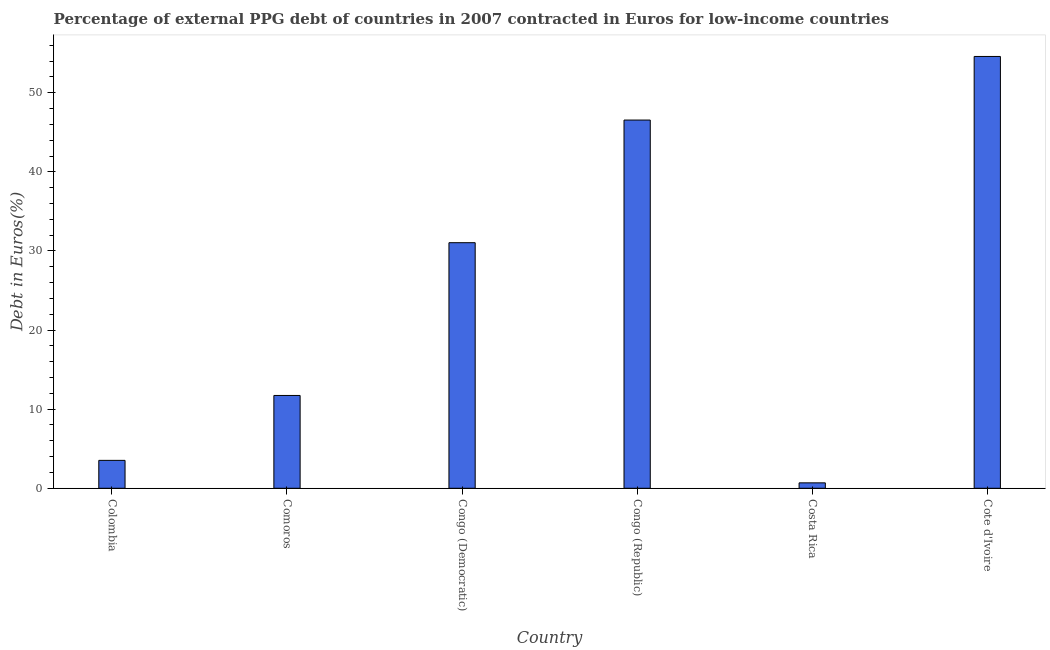Does the graph contain any zero values?
Ensure brevity in your answer.  No. What is the title of the graph?
Your response must be concise. Percentage of external PPG debt of countries in 2007 contracted in Euros for low-income countries. What is the label or title of the Y-axis?
Offer a very short reply. Debt in Euros(%). What is the currency composition of ppg debt in Costa Rica?
Provide a short and direct response. 0.69. Across all countries, what is the maximum currency composition of ppg debt?
Your answer should be compact. 54.59. Across all countries, what is the minimum currency composition of ppg debt?
Offer a very short reply. 0.69. In which country was the currency composition of ppg debt maximum?
Offer a terse response. Cote d'Ivoire. In which country was the currency composition of ppg debt minimum?
Provide a succinct answer. Costa Rica. What is the sum of the currency composition of ppg debt?
Your response must be concise. 148.14. What is the difference between the currency composition of ppg debt in Colombia and Comoros?
Ensure brevity in your answer.  -8.2. What is the average currency composition of ppg debt per country?
Offer a terse response. 24.69. What is the median currency composition of ppg debt?
Keep it short and to the point. 21.39. What is the ratio of the currency composition of ppg debt in Congo (Republic) to that in Cote d'Ivoire?
Your answer should be compact. 0.85. What is the difference between the highest and the second highest currency composition of ppg debt?
Provide a short and direct response. 8.04. Is the sum of the currency composition of ppg debt in Congo (Democratic) and Cote d'Ivoire greater than the maximum currency composition of ppg debt across all countries?
Keep it short and to the point. Yes. What is the difference between the highest and the lowest currency composition of ppg debt?
Offer a very short reply. 53.9. In how many countries, is the currency composition of ppg debt greater than the average currency composition of ppg debt taken over all countries?
Your answer should be very brief. 3. Are all the bars in the graph horizontal?
Your answer should be compact. No. What is the Debt in Euros(%) of Colombia?
Provide a succinct answer. 3.53. What is the Debt in Euros(%) in Comoros?
Provide a short and direct response. 11.73. What is the Debt in Euros(%) of Congo (Democratic)?
Make the answer very short. 31.05. What is the Debt in Euros(%) of Congo (Republic)?
Offer a very short reply. 46.55. What is the Debt in Euros(%) of Costa Rica?
Offer a terse response. 0.69. What is the Debt in Euros(%) of Cote d'Ivoire?
Offer a terse response. 54.59. What is the difference between the Debt in Euros(%) in Colombia and Comoros?
Your answer should be compact. -8.2. What is the difference between the Debt in Euros(%) in Colombia and Congo (Democratic)?
Your response must be concise. -27.52. What is the difference between the Debt in Euros(%) in Colombia and Congo (Republic)?
Make the answer very short. -43.02. What is the difference between the Debt in Euros(%) in Colombia and Costa Rica?
Make the answer very short. 2.84. What is the difference between the Debt in Euros(%) in Colombia and Cote d'Ivoire?
Offer a terse response. -51.06. What is the difference between the Debt in Euros(%) in Comoros and Congo (Democratic)?
Provide a short and direct response. -19.31. What is the difference between the Debt in Euros(%) in Comoros and Congo (Republic)?
Ensure brevity in your answer.  -34.82. What is the difference between the Debt in Euros(%) in Comoros and Costa Rica?
Offer a very short reply. 11.05. What is the difference between the Debt in Euros(%) in Comoros and Cote d'Ivoire?
Provide a short and direct response. -42.86. What is the difference between the Debt in Euros(%) in Congo (Democratic) and Congo (Republic)?
Make the answer very short. -15.51. What is the difference between the Debt in Euros(%) in Congo (Democratic) and Costa Rica?
Your answer should be compact. 30.36. What is the difference between the Debt in Euros(%) in Congo (Democratic) and Cote d'Ivoire?
Your answer should be compact. -23.54. What is the difference between the Debt in Euros(%) in Congo (Republic) and Costa Rica?
Your answer should be compact. 45.86. What is the difference between the Debt in Euros(%) in Congo (Republic) and Cote d'Ivoire?
Give a very brief answer. -8.04. What is the difference between the Debt in Euros(%) in Costa Rica and Cote d'Ivoire?
Your answer should be very brief. -53.9. What is the ratio of the Debt in Euros(%) in Colombia to that in Comoros?
Your answer should be very brief. 0.3. What is the ratio of the Debt in Euros(%) in Colombia to that in Congo (Democratic)?
Your answer should be compact. 0.11. What is the ratio of the Debt in Euros(%) in Colombia to that in Congo (Republic)?
Your answer should be very brief. 0.08. What is the ratio of the Debt in Euros(%) in Colombia to that in Costa Rica?
Ensure brevity in your answer.  5.14. What is the ratio of the Debt in Euros(%) in Colombia to that in Cote d'Ivoire?
Ensure brevity in your answer.  0.07. What is the ratio of the Debt in Euros(%) in Comoros to that in Congo (Democratic)?
Your answer should be compact. 0.38. What is the ratio of the Debt in Euros(%) in Comoros to that in Congo (Republic)?
Make the answer very short. 0.25. What is the ratio of the Debt in Euros(%) in Comoros to that in Costa Rica?
Ensure brevity in your answer.  17.08. What is the ratio of the Debt in Euros(%) in Comoros to that in Cote d'Ivoire?
Provide a succinct answer. 0.21. What is the ratio of the Debt in Euros(%) in Congo (Democratic) to that in Congo (Republic)?
Your response must be concise. 0.67. What is the ratio of the Debt in Euros(%) in Congo (Democratic) to that in Costa Rica?
Keep it short and to the point. 45.18. What is the ratio of the Debt in Euros(%) in Congo (Democratic) to that in Cote d'Ivoire?
Your answer should be very brief. 0.57. What is the ratio of the Debt in Euros(%) in Congo (Republic) to that in Costa Rica?
Give a very brief answer. 67.75. What is the ratio of the Debt in Euros(%) in Congo (Republic) to that in Cote d'Ivoire?
Give a very brief answer. 0.85. What is the ratio of the Debt in Euros(%) in Costa Rica to that in Cote d'Ivoire?
Offer a terse response. 0.01. 